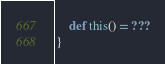Convert code to text. <code><loc_0><loc_0><loc_500><loc_500><_Scala_>    def this() = ???
}
</code> 